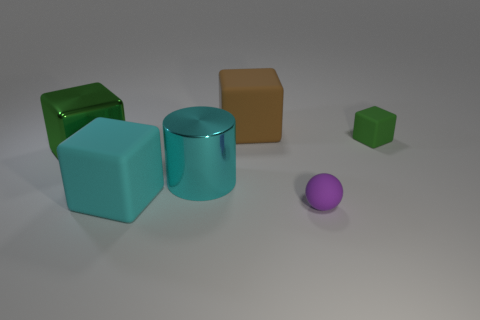Are there an equal number of big cyan cubes in front of the tiny matte ball and tiny purple objects?
Keep it short and to the point. No. How big is the cyan thing in front of the big cyan shiny object?
Offer a very short reply. Large. What number of big things are brown rubber things or blue rubber balls?
Offer a very short reply. 1. The other tiny object that is the same shape as the green metal thing is what color?
Your answer should be compact. Green. Do the cyan block and the cyan shiny object have the same size?
Offer a terse response. Yes. How many objects are tiny yellow cubes or large cyan objects that are in front of the large cyan metallic object?
Keep it short and to the point. 1. There is a small object behind the tiny purple thing that is in front of the cyan cube; what color is it?
Your answer should be very brief. Green. There is a large object that is in front of the big cyan metal cylinder; does it have the same color as the small matte cube?
Give a very brief answer. No. There is a green cube that is on the left side of the tiny block; what is its material?
Give a very brief answer. Metal. The cyan matte thing has what size?
Give a very brief answer. Large. 